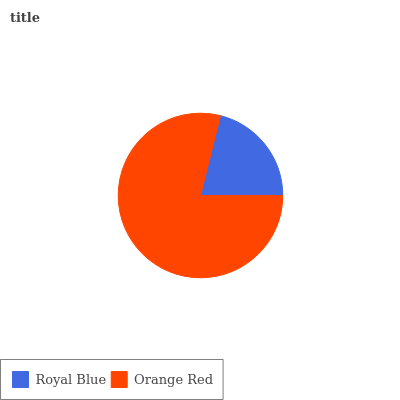Is Royal Blue the minimum?
Answer yes or no. Yes. Is Orange Red the maximum?
Answer yes or no. Yes. Is Orange Red the minimum?
Answer yes or no. No. Is Orange Red greater than Royal Blue?
Answer yes or no. Yes. Is Royal Blue less than Orange Red?
Answer yes or no. Yes. Is Royal Blue greater than Orange Red?
Answer yes or no. No. Is Orange Red less than Royal Blue?
Answer yes or no. No. Is Orange Red the high median?
Answer yes or no. Yes. Is Royal Blue the low median?
Answer yes or no. Yes. Is Royal Blue the high median?
Answer yes or no. No. Is Orange Red the low median?
Answer yes or no. No. 